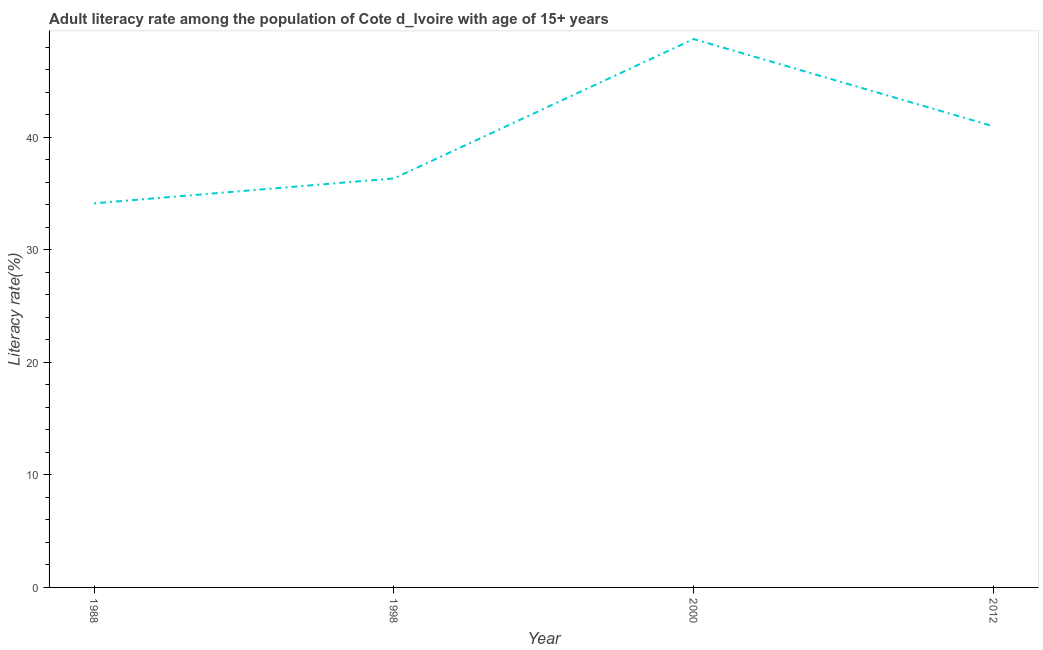What is the adult literacy rate in 2000?
Give a very brief answer. 48.74. Across all years, what is the maximum adult literacy rate?
Your answer should be compact. 48.74. Across all years, what is the minimum adult literacy rate?
Your answer should be very brief. 34.14. In which year was the adult literacy rate minimum?
Your answer should be compact. 1988. What is the sum of the adult literacy rate?
Ensure brevity in your answer.  160.21. What is the difference between the adult literacy rate in 1998 and 2000?
Provide a short and direct response. -12.39. What is the average adult literacy rate per year?
Your response must be concise. 40.05. What is the median adult literacy rate?
Offer a very short reply. 38.67. Do a majority of the years between 2000 and 1988 (inclusive) have adult literacy rate greater than 20 %?
Offer a very short reply. No. What is the ratio of the adult literacy rate in 1998 to that in 2012?
Your answer should be compact. 0.89. Is the difference between the adult literacy rate in 2000 and 2012 greater than the difference between any two years?
Keep it short and to the point. No. What is the difference between the highest and the second highest adult literacy rate?
Offer a very short reply. 7.76. What is the difference between the highest and the lowest adult literacy rate?
Give a very brief answer. 14.6. In how many years, is the adult literacy rate greater than the average adult literacy rate taken over all years?
Give a very brief answer. 2. How many lines are there?
Your answer should be compact. 1. How many years are there in the graph?
Provide a short and direct response. 4. Does the graph contain grids?
Provide a short and direct response. No. What is the title of the graph?
Make the answer very short. Adult literacy rate among the population of Cote d_Ivoire with age of 15+ years. What is the label or title of the X-axis?
Provide a short and direct response. Year. What is the label or title of the Y-axis?
Your answer should be very brief. Literacy rate(%). What is the Literacy rate(%) in 1988?
Your answer should be compact. 34.14. What is the Literacy rate(%) in 1998?
Your response must be concise. 36.35. What is the Literacy rate(%) in 2000?
Provide a succinct answer. 48.74. What is the Literacy rate(%) in 2012?
Keep it short and to the point. 40.98. What is the difference between the Literacy rate(%) in 1988 and 1998?
Ensure brevity in your answer.  -2.21. What is the difference between the Literacy rate(%) in 1988 and 2000?
Provide a short and direct response. -14.6. What is the difference between the Literacy rate(%) in 1988 and 2012?
Make the answer very short. -6.84. What is the difference between the Literacy rate(%) in 1998 and 2000?
Ensure brevity in your answer.  -12.39. What is the difference between the Literacy rate(%) in 1998 and 2012?
Give a very brief answer. -4.63. What is the difference between the Literacy rate(%) in 2000 and 2012?
Make the answer very short. 7.76. What is the ratio of the Literacy rate(%) in 1988 to that in 1998?
Your answer should be very brief. 0.94. What is the ratio of the Literacy rate(%) in 1988 to that in 2000?
Your answer should be compact. 0.7. What is the ratio of the Literacy rate(%) in 1988 to that in 2012?
Keep it short and to the point. 0.83. What is the ratio of the Literacy rate(%) in 1998 to that in 2000?
Offer a terse response. 0.75. What is the ratio of the Literacy rate(%) in 1998 to that in 2012?
Keep it short and to the point. 0.89. What is the ratio of the Literacy rate(%) in 2000 to that in 2012?
Provide a short and direct response. 1.19. 